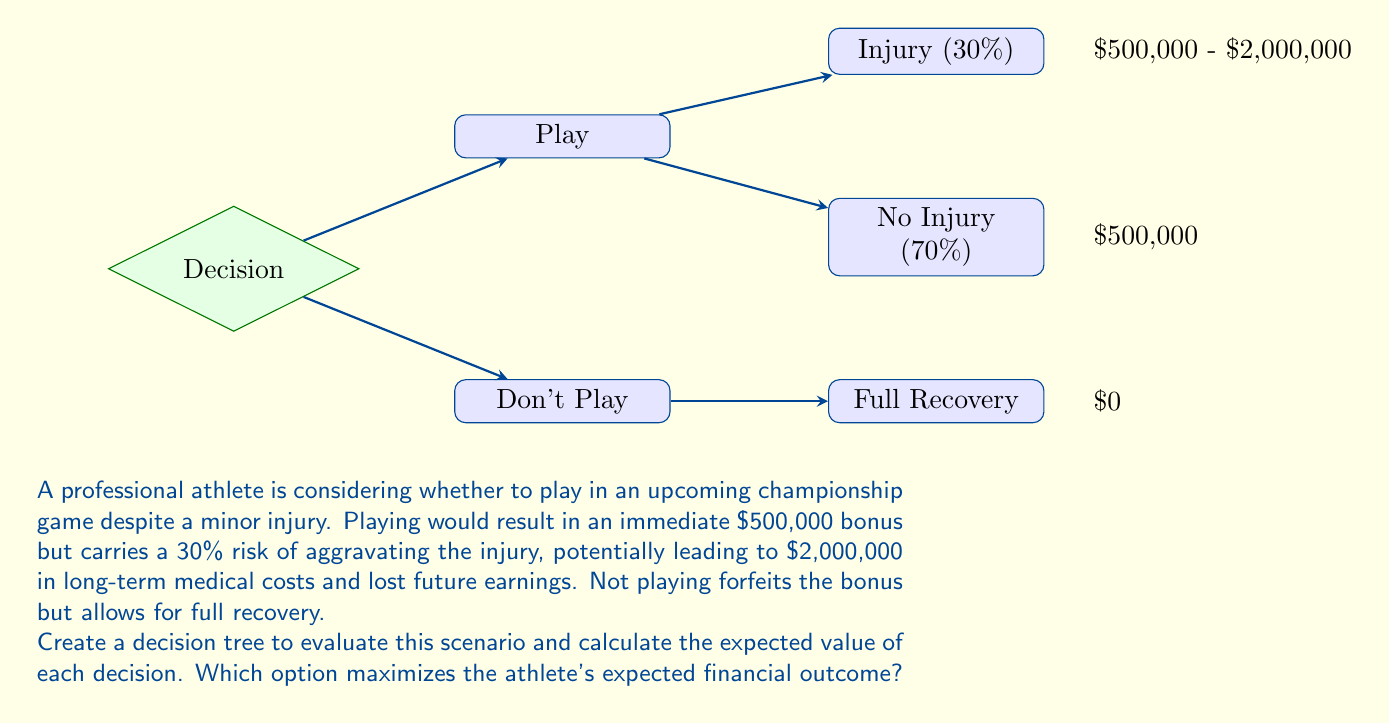Could you help me with this problem? Let's approach this problem step-by-step using decision tree analysis:

1) First, let's identify the two main decisions:
   - Play in the game
   - Don't play in the game

2) For the "Play" decision:
   - There's a 30% chance of injury:
     Expected value = $500,000 (bonus) - $2,000,000 (long-term costs) = -$1,500,000
   - There's a 70% chance of no injury:
     Expected value = $500,000 (bonus)

3) Calculate the expected value of the "Play" decision:
   $$EV(\text{Play}) = 0.3 \times (-\$1,500,000) + 0.7 \times \$500,000$$
   $$EV(\text{Play}) = -\$450,000 + \$350,000 = -\$100,000$$

4) For the "Don't Play" decision:
   - The outcome is certain: $0

5) Compare the expected values:
   - Play: -$100,000
   - Don't Play: $0

6) The option that maximizes the expected financial outcome is the one with the higher expected value.
Answer: Don't Play ($0 > -$100,000) 